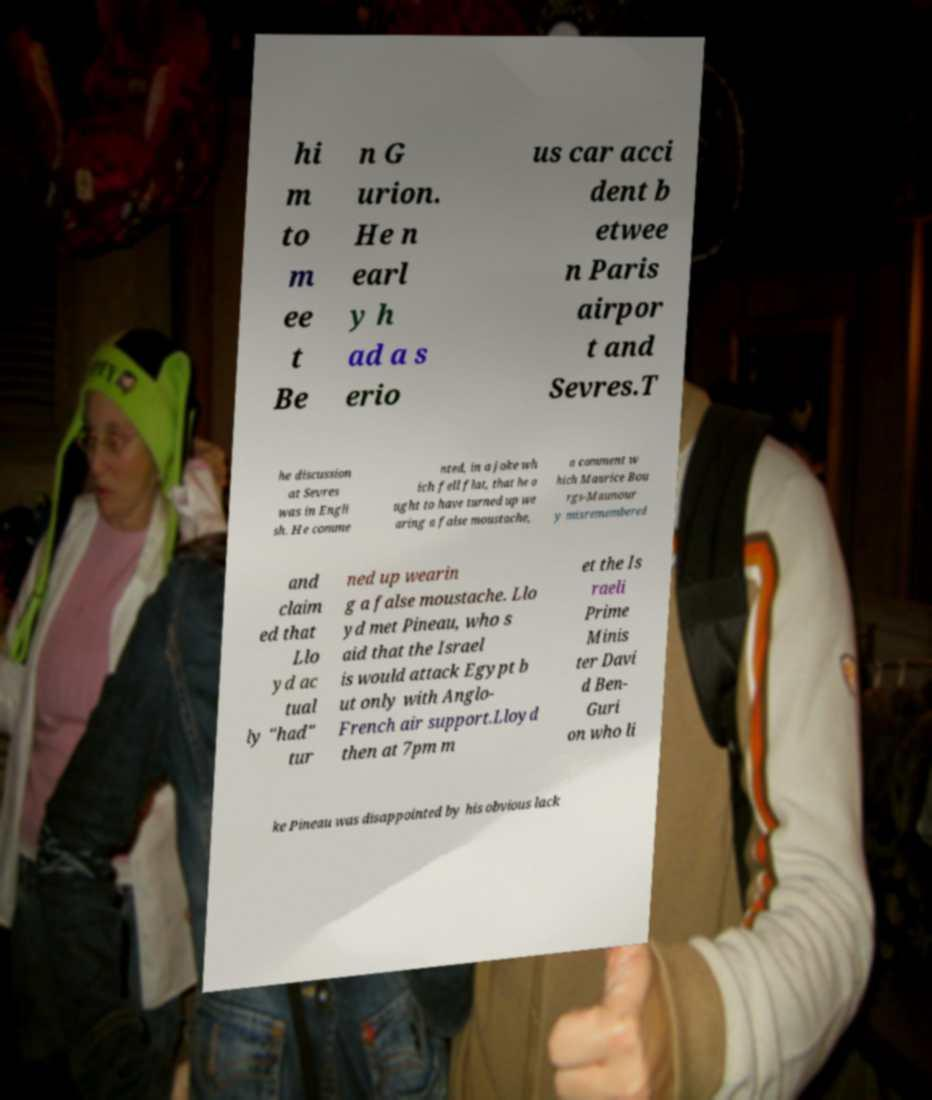For documentation purposes, I need the text within this image transcribed. Could you provide that? hi m to m ee t Be n G urion. He n earl y h ad a s erio us car acci dent b etwee n Paris airpor t and Sevres.T he discussion at Sevres was in Engli sh. He comme nted, in a joke wh ich fell flat, that he o ught to have turned up we aring a false moustache, a comment w hich Maurice Bou rgs-Maunour y misremembered and claim ed that Llo yd ac tual ly "had" tur ned up wearin g a false moustache. Llo yd met Pineau, who s aid that the Israel is would attack Egypt b ut only with Anglo- French air support.Lloyd then at 7pm m et the Is raeli Prime Minis ter Davi d Ben- Guri on who li ke Pineau was disappointed by his obvious lack 